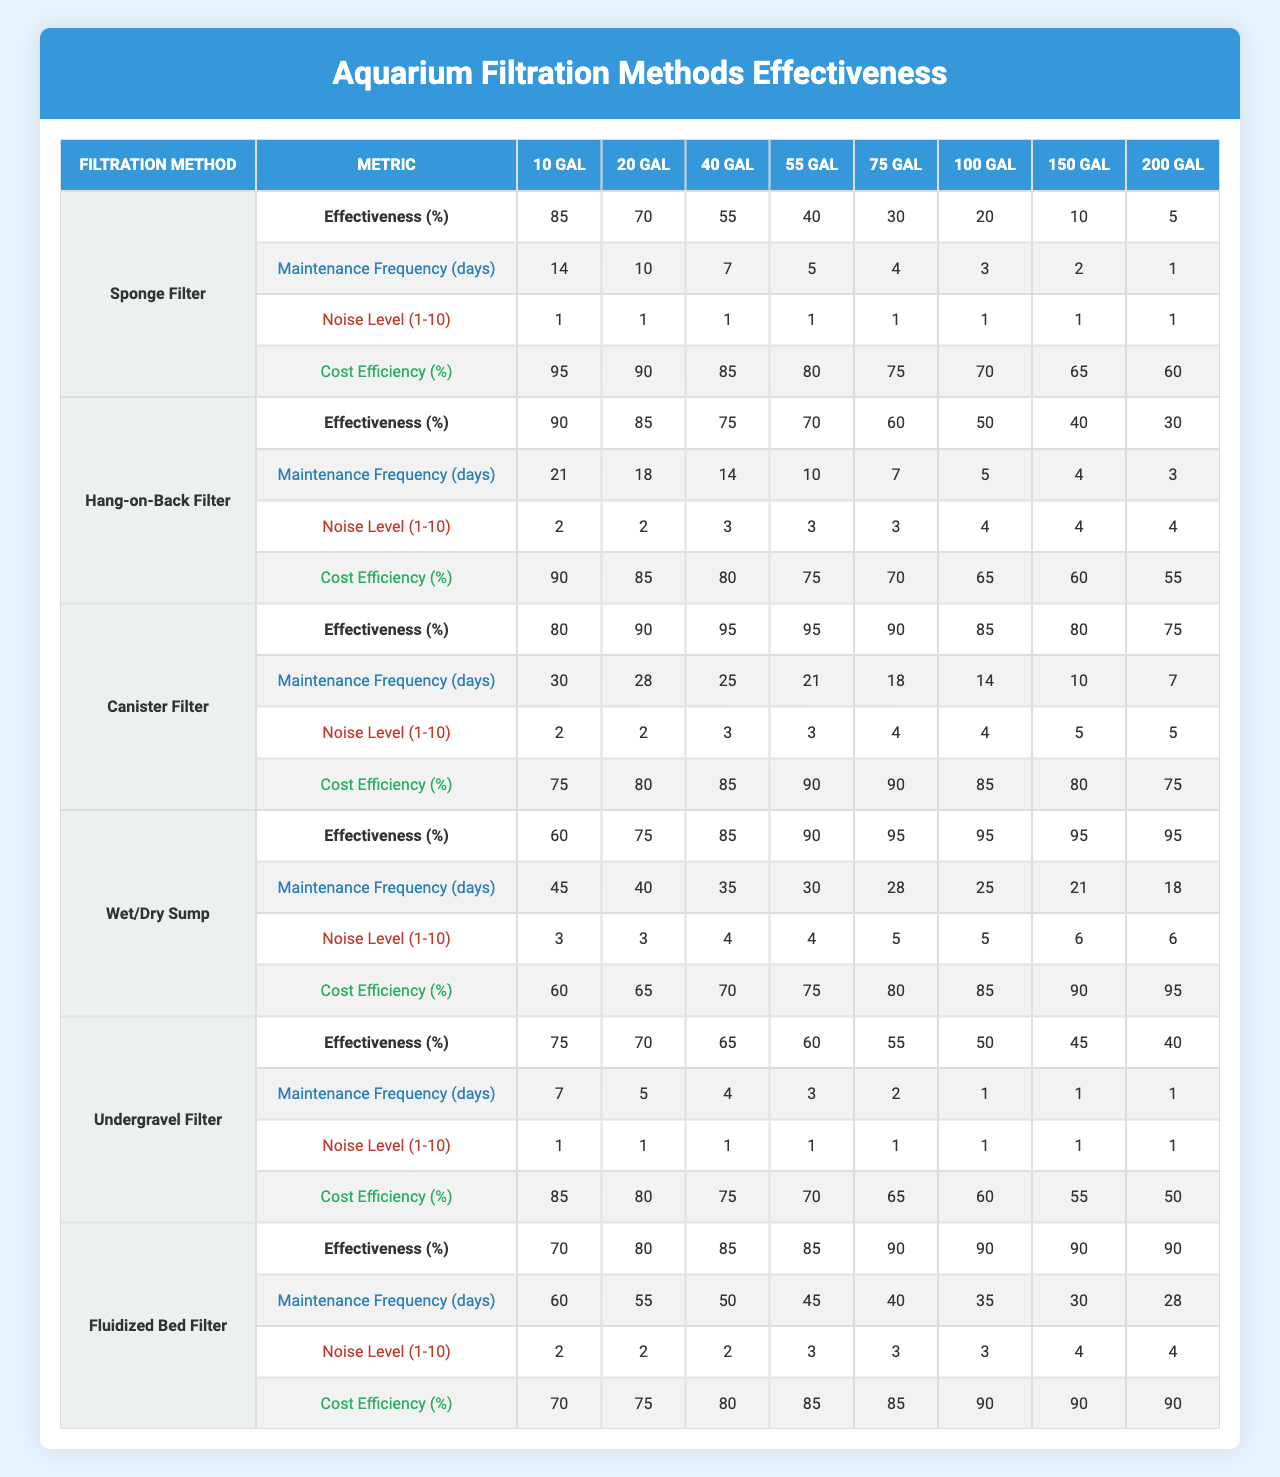What is the effectiveness of the Canister Filter in a 40-gallon tank? According to the table, the effectiveness of the Canister Filter in a 40-gallon tank is indicated under the effectiveness row corresponding to the Canister Filter and the 40-gallon column, which shows a value of 95%.
Answer: 95% Which filtration method has the highest effectiveness for a 10-gallon tank? The table shows that the effectiveness for the 10-gallon tank is highest under the Hang-on-Back Filter, with an effectiveness of 90%.
Answer: Hang-on-Back Filter What is the average maintenance frequency for the Wet/Dry Sump across all tank sizes? To find the average maintenance frequency for the Wet/Dry Sump, we sum all the maintenance values across the 8 tank sizes (45 + 40 + 35 + 30 + 28 + 25 + 21 + 18 =  288), then divide by 8, which gives us an average of 36 days.
Answer: 36 days Is the noise level of the Undergravel Filter consistent across all tank sizes? Inspecting the noise level rows in the table shows that the Undergravel Filter has a consistent noise level of 1 across all tank sizes, meaning it does not vary.
Answer: Yes Which filtration method requires the least maintenance for a 75-gallon tank? Looking at the table, the maintenance frequency for the 75-gallon tank for all filtration methods shows that the Undergravel Filter requires only 1 day of maintenance, which is the least compared to the others.
Answer: Undergravel Filter How does the cost efficiency of the Sponge Filter compare to the Canister Filter for a 100-gallon tank? The cost efficiency for the Sponge Filter is 70% while for the Canister Filter, it is 85%. Taking the difference, the Canister Filter is more cost-efficient by 15%.
Answer: Canister Filter is more cost-efficient What is the trend of effectiveness as the tank size increases for the Fluidized Bed Filter? Analyzing the effectiveness for the Fluidized Bed Filter, we see that the values decrease as the tank sizes increase from 10 gallons (70%) to 200 gallons (90%). Thus, the trend shows that the effectiveness increases with tank size for this filtration method.
Answer: Effectiveness increases with tank size Which filtration method has the highest noise level in a 55-gallon tank? Evaluating the noise levels in the 55-gallon column, the Wet/Dry Sump has the highest noise level of 5, which is higher than any other filtration method listed for that tank size.
Answer: Wet/Dry Sump What is the minimum maintenance frequency for any filtration method across all tank sizes? By reviewing the maintenance frequencies for all methodologies and tank sizes, it appears that the Undergravel Filter and the Hang-on-Back Filter both require a minimum of 1 day of maintenance under some tank sizes, and hence, this is the lowest value noted in the table.
Answer: 1 day 